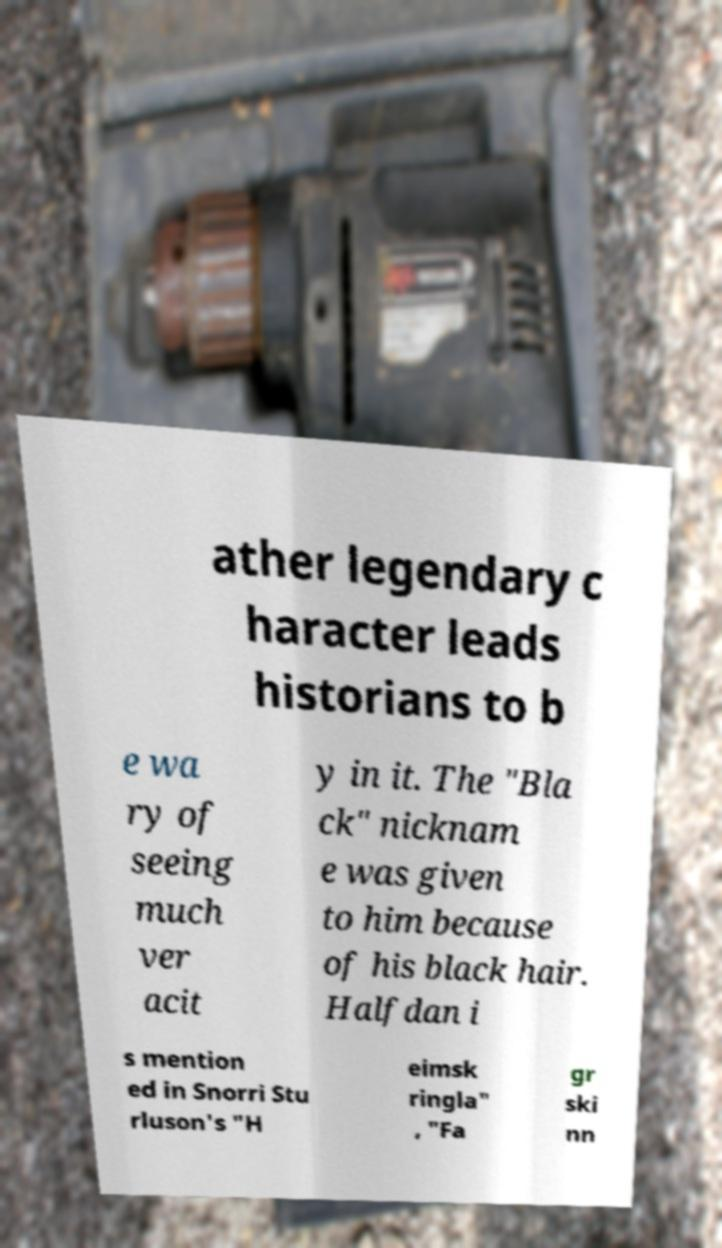I need the written content from this picture converted into text. Can you do that? ather legendary c haracter leads historians to b e wa ry of seeing much ver acit y in it. The "Bla ck" nicknam e was given to him because of his black hair. Halfdan i s mention ed in Snorri Stu rluson's "H eimsk ringla" , "Fa gr ski nn 